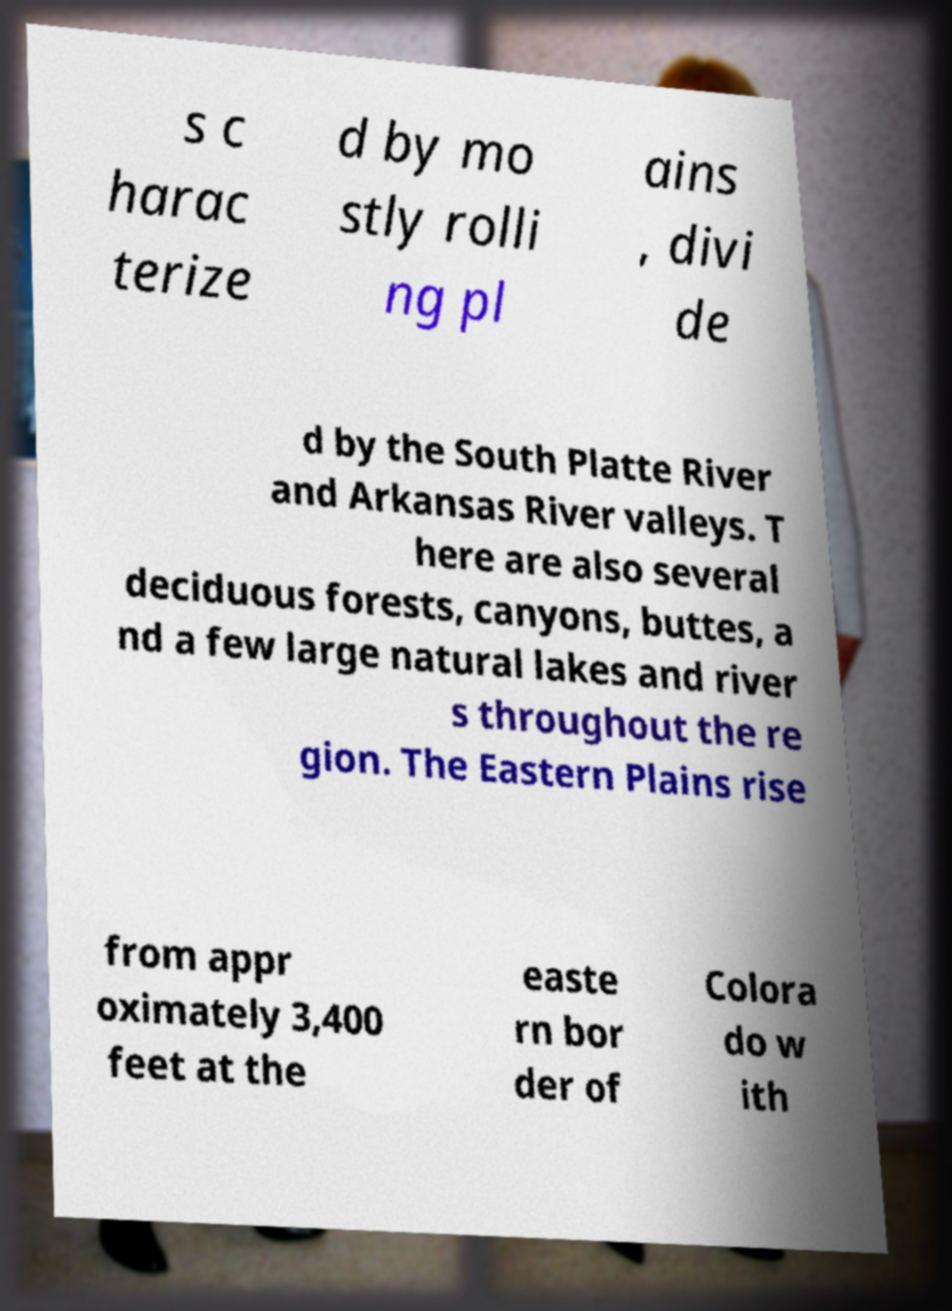I need the written content from this picture converted into text. Can you do that? s c harac terize d by mo stly rolli ng pl ains , divi de d by the South Platte River and Arkansas River valleys. T here are also several deciduous forests, canyons, buttes, a nd a few large natural lakes and river s throughout the re gion. The Eastern Plains rise from appr oximately 3,400 feet at the easte rn bor der of Colora do w ith 